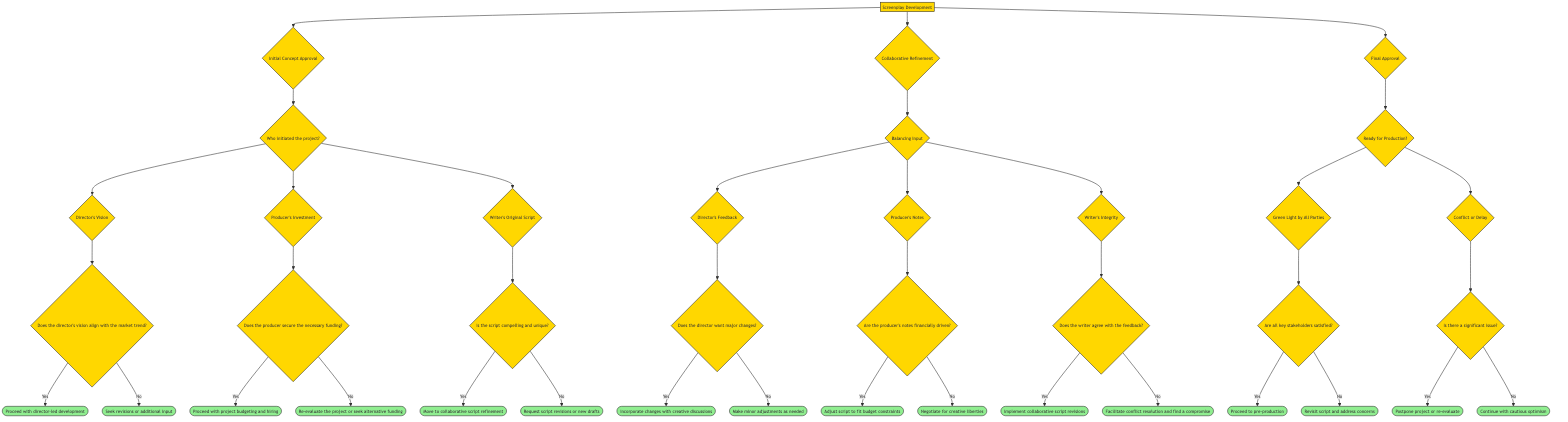What is the first decision node in the diagram? The first decision node in the diagram is labeled "Initial Concept Approval," which is the first major point where decisions regarding screenplay development are made.
Answer: Initial Concept Approval How many options are available under "Initial Concept Approval"? There are three options available under "Initial Concept Approval": "Director's Vision," "Producer's Investment," and "Writer's Original Script."
Answer: 3 What is the outcome if the producer secures funding? If the producer secures the necessary funding, the outcome is "Proceed with project budgeting and hiring," indicating that the project can move forward financially.
Answer: Proceed with project budgeting and hiring Does the writer's script need to be compelling to proceed to collaborative refinement? Yes, the writer's original script must be compelling and unique to move to the next stage of collaborative script refinement; otherwise, script revisions or new drafts are requested.
Answer: Yes What happens if there is conflict or delay during final approval? If there is a significant issue during final approval, the action taken is to "Postpone project or re-evaluate," indicating that the project will not proceed until concerns are resolved.
Answer: Postpone project or re-evaluate Are the producer's notes more likely to be financially driven? Yes, one of the questions asked in the "Producer's Notes" section specifically checks if the notes are financially driven, which influences the subsequent decisions on the script.
Answer: Yes What will happen if all key stakeholders are satisfied with the project? If all key stakeholders are satisfied, the next step is to "Proceed to pre-production," indicating that they are ready to move towards actual production.
Answer: Proceed to pre-production What decision is made if the director wants major changes? If the director wants major changes, the outcome is to "Incorporate changes with creative discussions," meaning they will work together to modify the script.
Answer: Incorporate changes with creative discussions If the writer disagrees with the feedback, what is the suggested action? If the writer disagrees with the feedback, the action suggested is to "Facilitate conflict resolution and find a compromise," indicating that a collaborative solution is sought.
Answer: Facilitate conflict resolution and find a compromise 